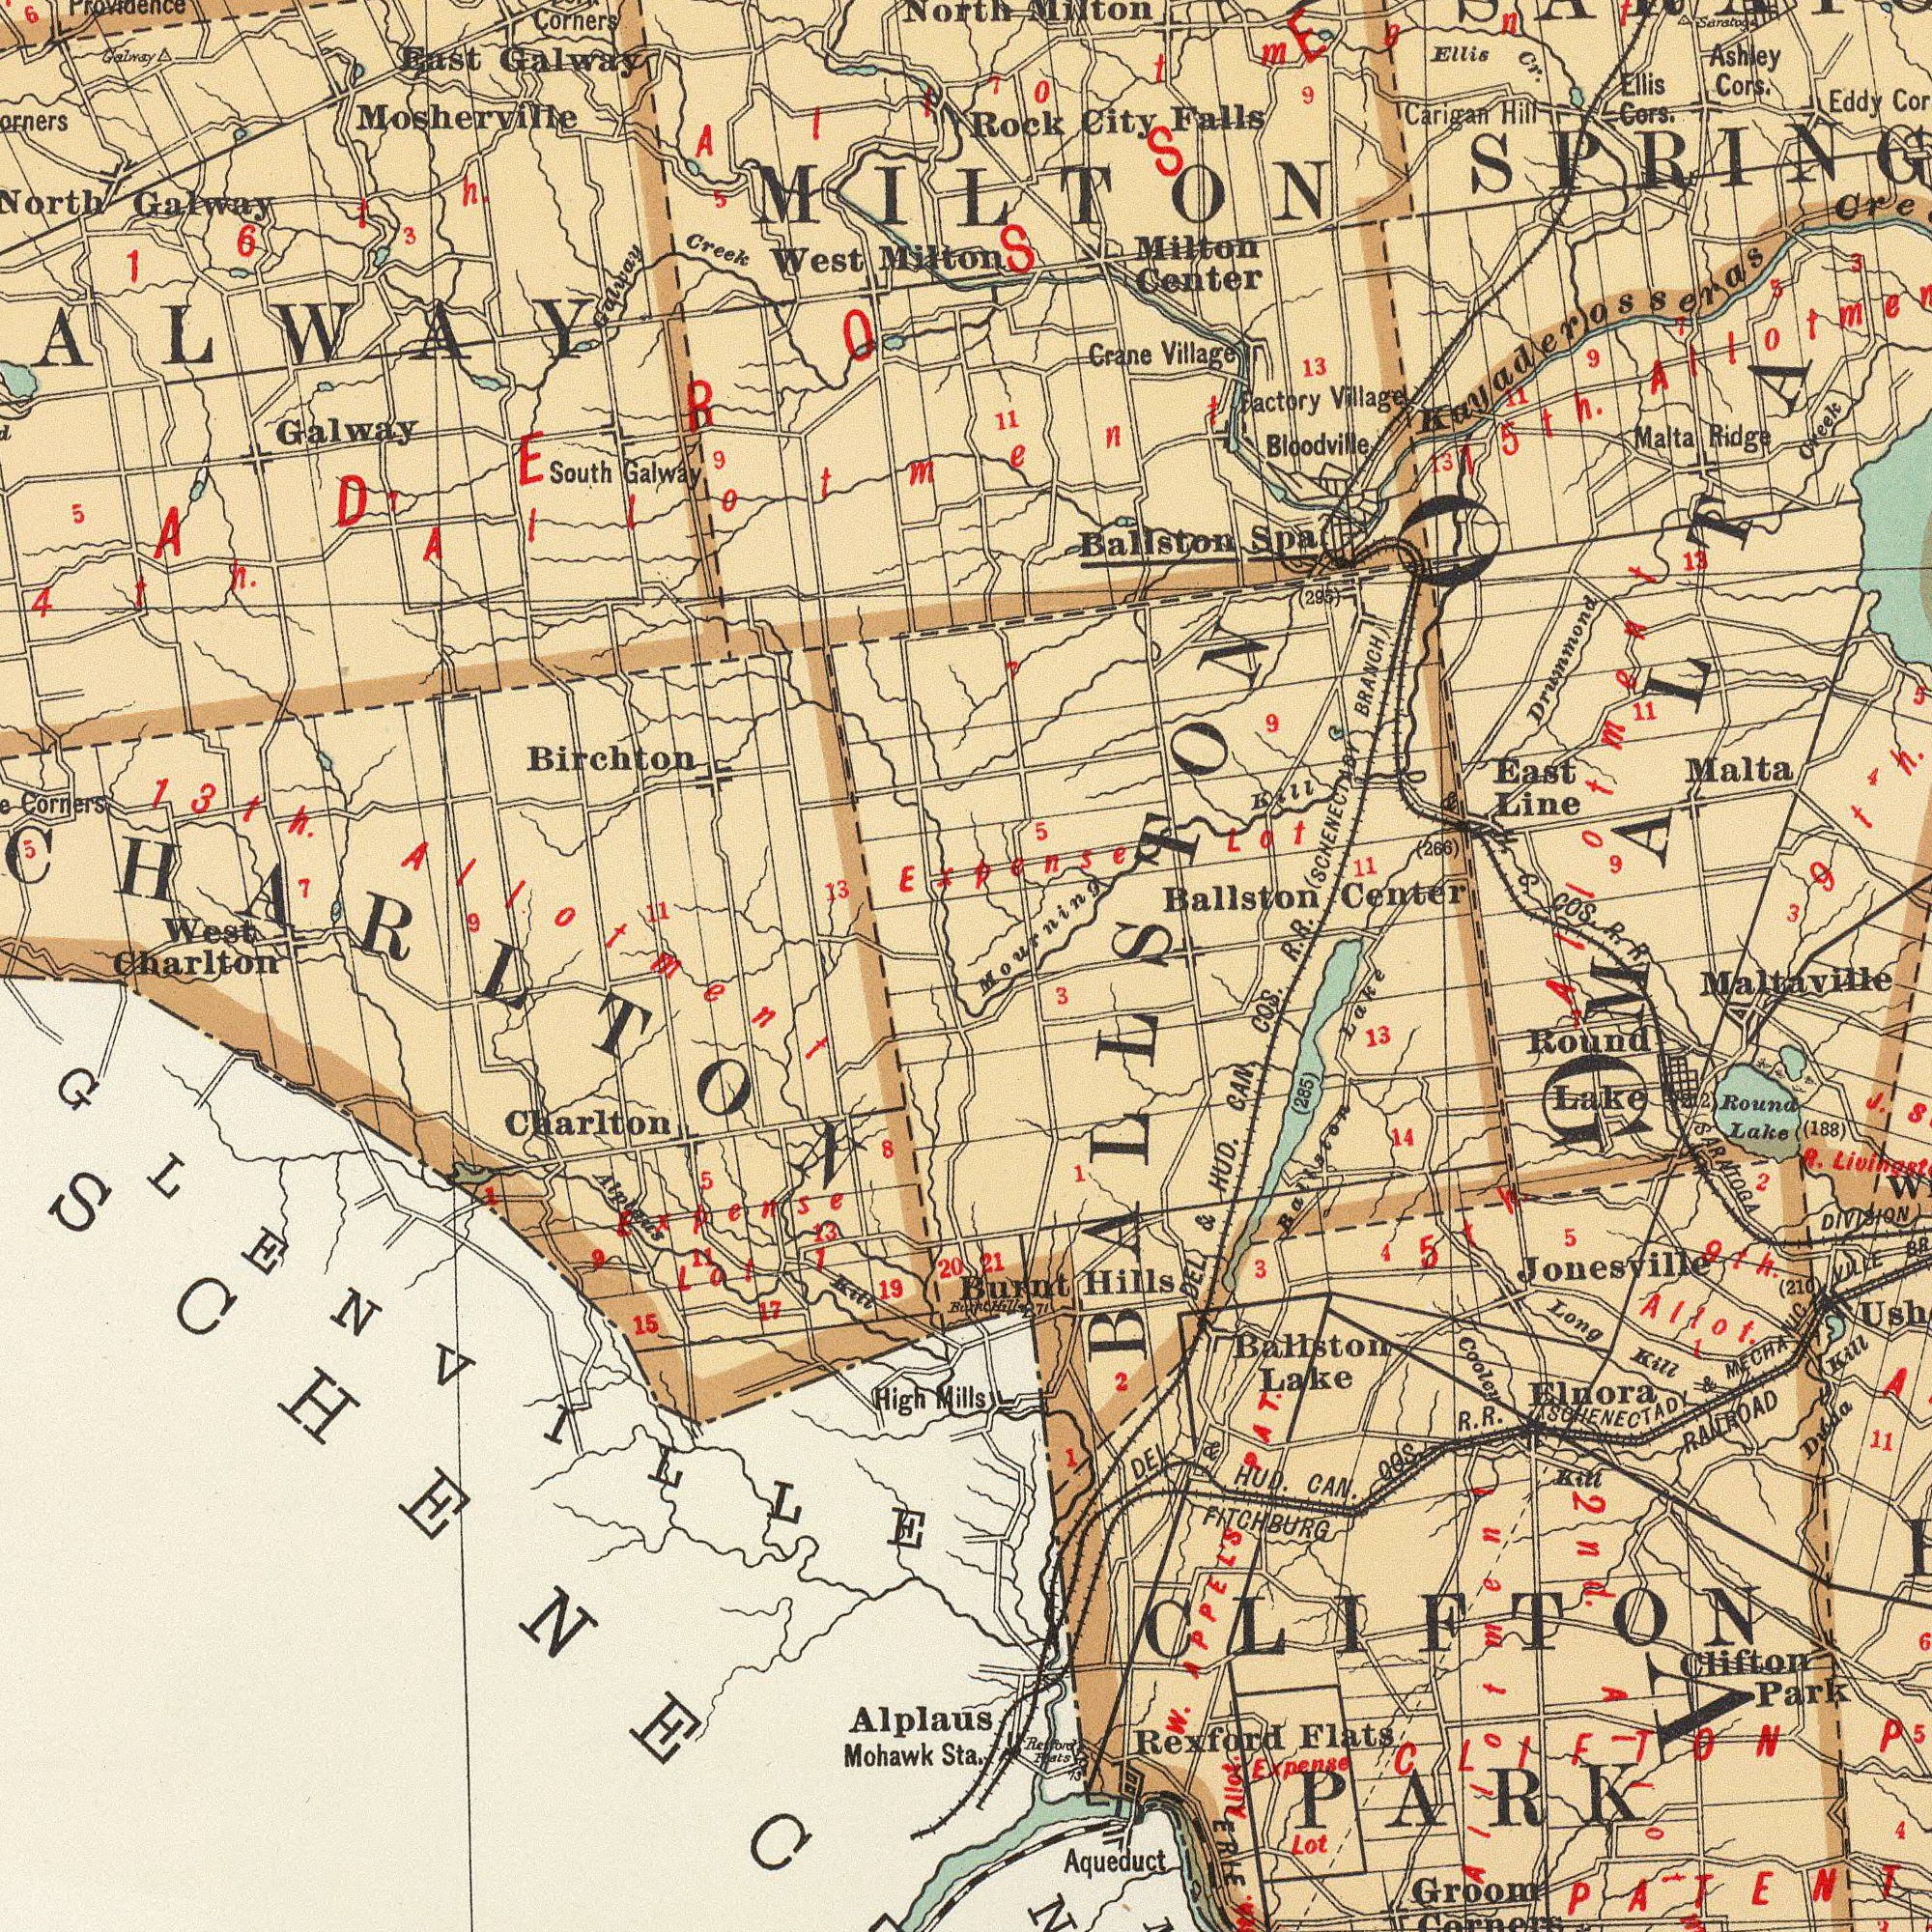What text can you see in the top-right section? Milton Ballston Center Ashley Cors. Milton Center Ballston Spa Rock City Falls Ellis Cors. D. & H. C. COS. R. R. R. R. (SCHENECIADY BRANCH) Carigan Hill East Line Malta Ridge Kayaderosseras Eddy Crane Village Factory Village 13 Drummond Creek Ellis Cr. Mourning Kill 13 (295) Expense Lot 11 11 9 3 15th. (266) Malta 13 MILTON Saratog 5 9 9 5 7 Bloodville 7 5 7 9 11 4 11 3 MALTA Allotment Allotment What text is shown in the bottom-right quadrant? DEL. & HUD. CAN. COS. Aqueduct Jonesville Groom FITCHBURG Kill RAILROAD Kill Ballston Lake (285) DEL. & HUD. CAN. OOS. R. R. SCHENECTADY & MECHANIC VILLE Lot Rexford Flats Round Lake Long Kill Clifton Park SARATOGA Round Lake 3 13 Elnora Duaa Cooley Ballston Lake Burnt Hills Expense 5 21 9th. Allot. 14 J. (188) Maltaville 3 ERLE (210) 11 CLIFTON W. APPL'S PAT. 1 Rexford Flats 2 R. 5 PATENT DIVISION Hill 73 4 4 2 1 CLIFTON PARK BALLSTON 5th 7 (212) 71 1 6 2nd. Allot. Allotment What text is shown in the top-left quadrant? Birchton Mosherville Galway West Milton Galway East Galway West Corners Galway Creek South Galway 13 Galway 3 North 6 9 5 13th. Allotment 11 Providence Corners 7 5 16 th. Allotment 5 9 7 What text can you see in the bottom-left section? Charlton Alplaus Kill Mohawk Sta. High Mills 19 20 Alplaus Charlton 5 17 Expens 8 13 15 Burnt GLENVILLE 1 9 11 Lot 1 